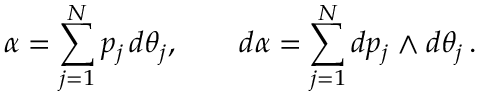Convert formula to latex. <formula><loc_0><loc_0><loc_500><loc_500>\alpha = \sum _ { j = 1 } ^ { N } p _ { j } \, d \theta _ { j } , \quad d \alpha = \sum _ { j = 1 } ^ { N } d p _ { j } \wedge d \theta _ { j } \, .</formula> 